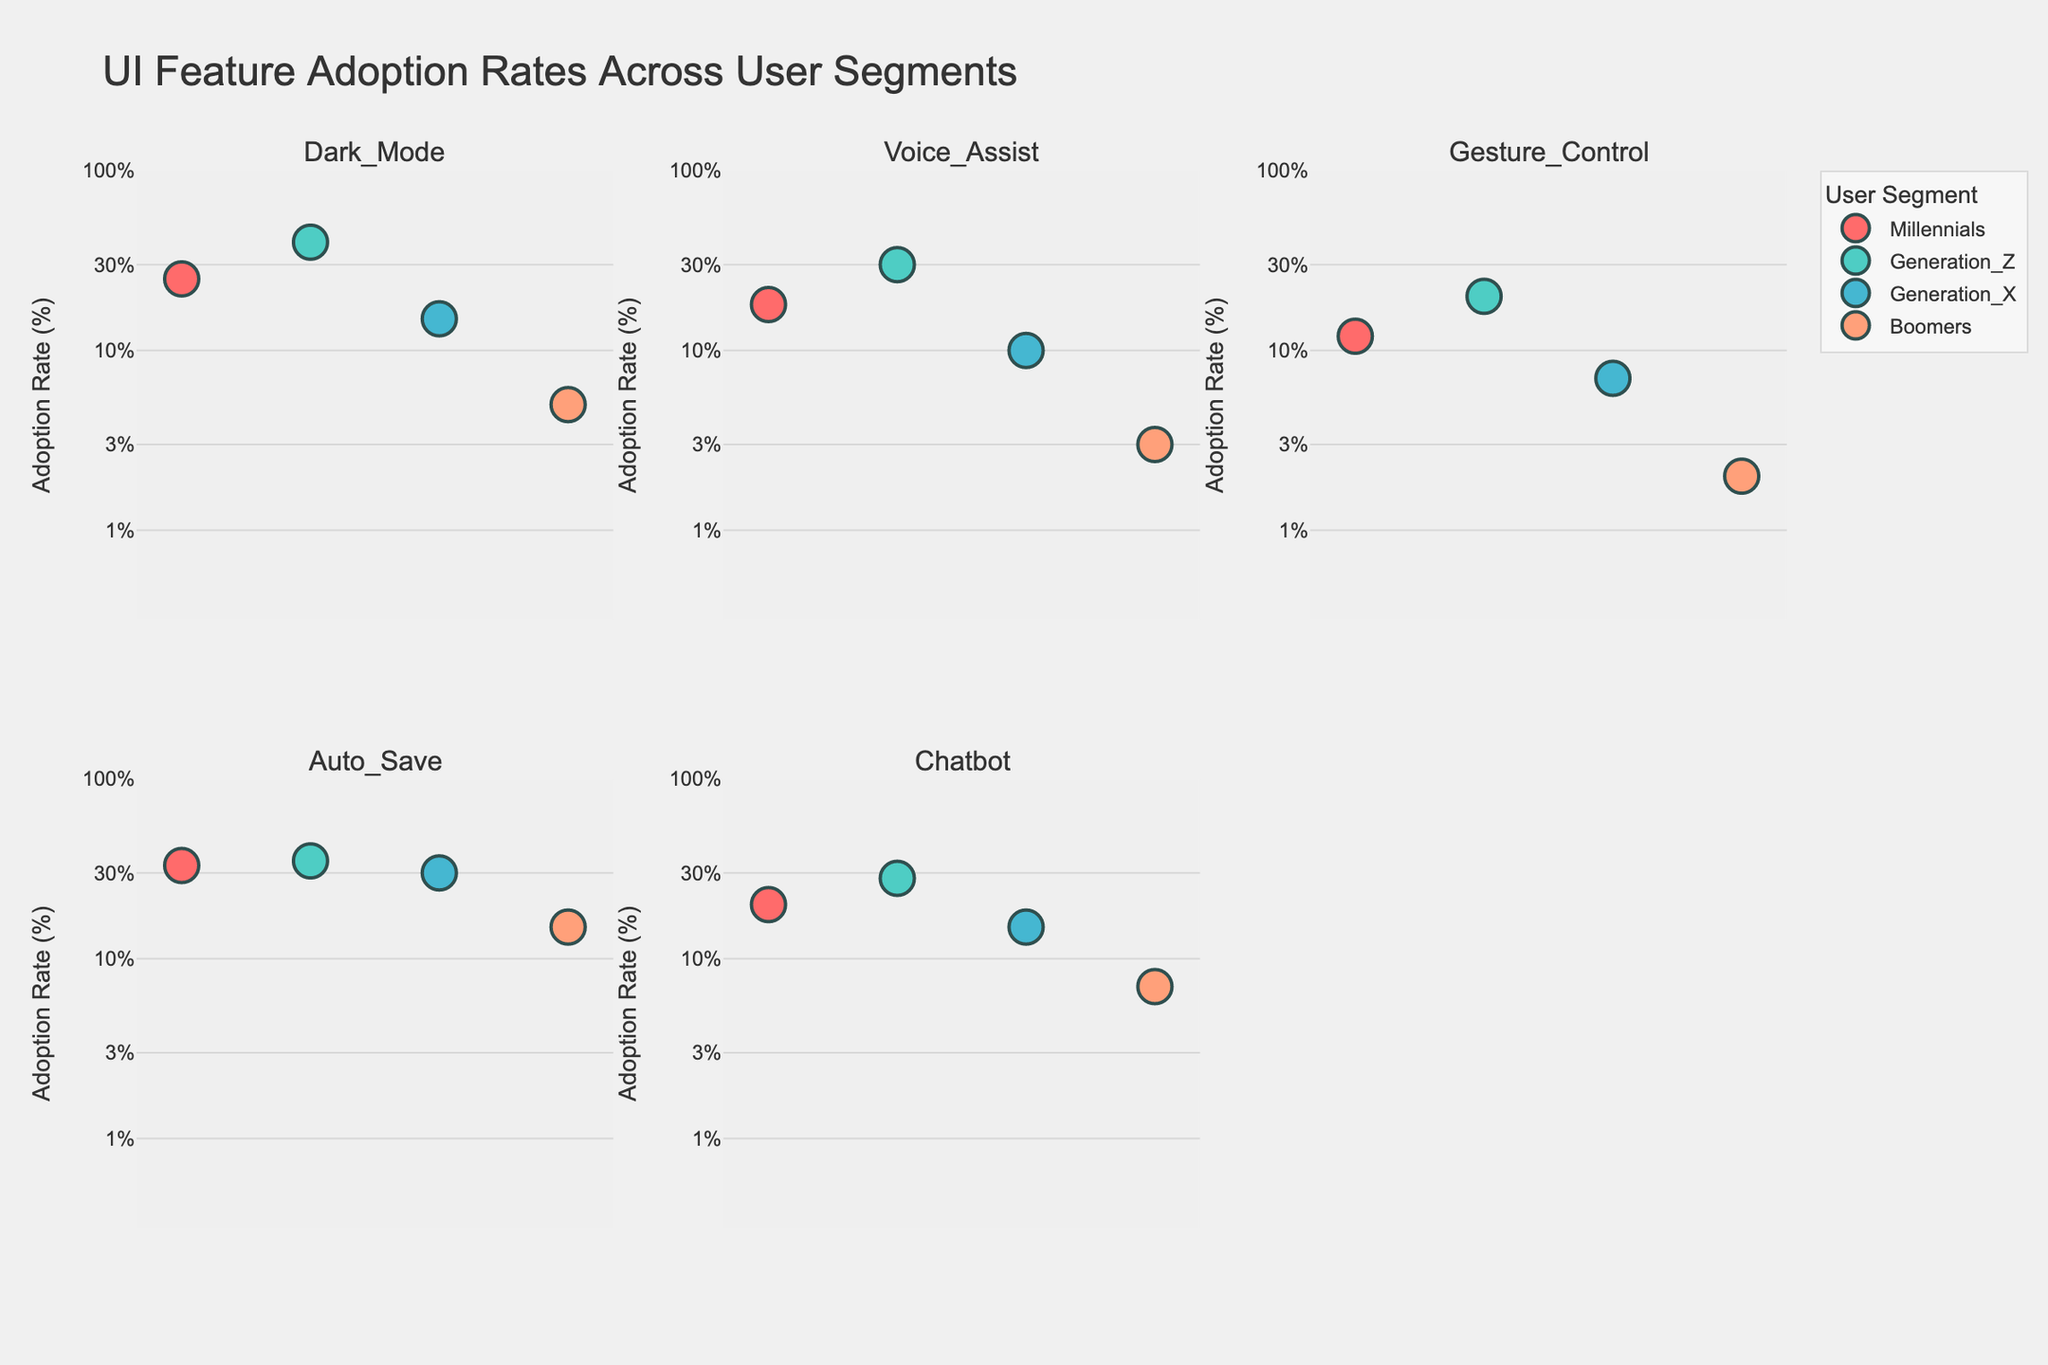What does the title of the figure say? The title is prominently displayed at the top of the figure, indicating the main subject of the plots.
Answer: "UI Feature Adoption Rates Across User Segments" Which user segment has the highest adoption rate for the "Dark Mode" feature? Looking at the subplot for "Dark Mode", you can see that the point for Generation Z is the highest of all user segments.
Answer: Generation Z What is the adoption rate of the "Voice Assist" feature for Boomers? Locate the subplot for "Voice Assist" and identify the point for Boomers. The adoption rate is marked as 3%.
Answer: 3% How many features show an adoption rate for Millennials above 20%? Observe each subplot and count the number of points for Millennials that are above the 20% mark on the y-axis. Dark Mode and Auto Save exceed 20%.
Answer: 2 What user segment shows the lowest adoption rate for the "Gesture Control" feature? Inspect the "Gesture Control" subplot, looking for the lowest point, which is for Boomers.
Answer: Boomers Compare the adoption rates of "Chatbot" between Generation X and Boomers. Look at the "Chatbot" subplot and compare the points for Generation X and Boomers. Generation X is at 15% and Boomers at 7%.
Answer: Generation X is larger Which feature has the most balanced adoption rates across all user segments? A balanced adoption rate would have points closer together. Observing all subplots, "Auto Save" has relatively close adoption rates.
Answer: Auto Save Calculate the average adoption rate of the "Dark Mode" feature across all user segments. Add the adoption rates for Dark Mode (25 + 40 + 15 + 5) and divide by 4. This gives (85/4) %.
Answer: 21.25% Which user segment has the most variability in adoption rates across all features? For each feature, observe the spread of points for each segment. Millennials' rates vary from 12% to 33% among the features, showing the largest variability.
Answer: Millennials Why might the use of a log scale be beneficial for visualizing this data? A log scale is beneficial for data that spans several orders of magnitude, making it easier to compare small and large values. Here, adoption rates range widely from 2% to 40%.
Answer: Easier comparison across a wide range of values 